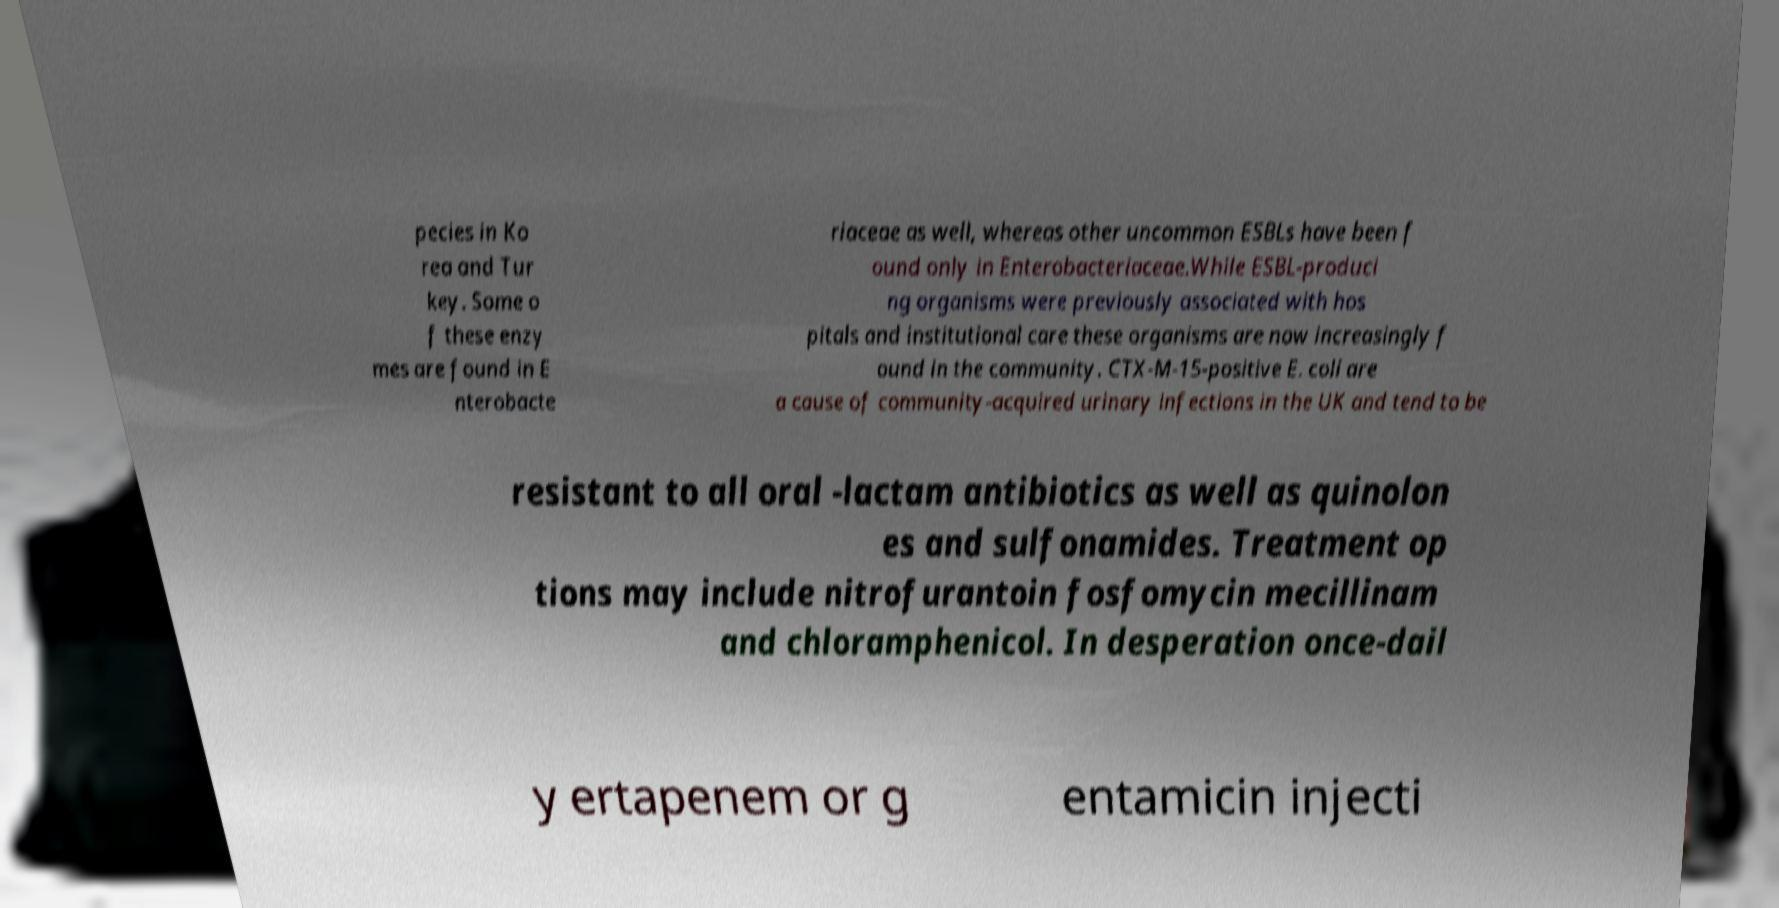I need the written content from this picture converted into text. Can you do that? pecies in Ko rea and Tur key. Some o f these enzy mes are found in E nterobacte riaceae as well, whereas other uncommon ESBLs have been f ound only in Enterobacteriaceae.While ESBL-produci ng organisms were previously associated with hos pitals and institutional care these organisms are now increasingly f ound in the community. CTX-M-15-positive E. coli are a cause of community-acquired urinary infections in the UK and tend to be resistant to all oral -lactam antibiotics as well as quinolon es and sulfonamides. Treatment op tions may include nitrofurantoin fosfomycin mecillinam and chloramphenicol. In desperation once-dail y ertapenem or g entamicin injecti 